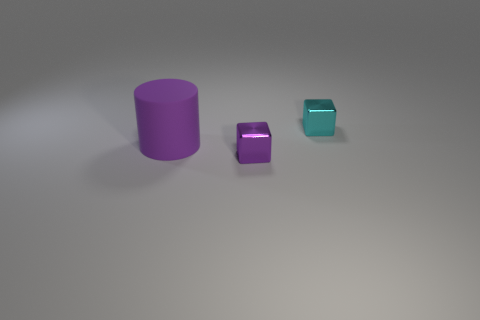Do the objects in the image have different textures or are they similar? The objects appear to have similar matte textures, giving them a uniform look despite their different shapes and sizes. 